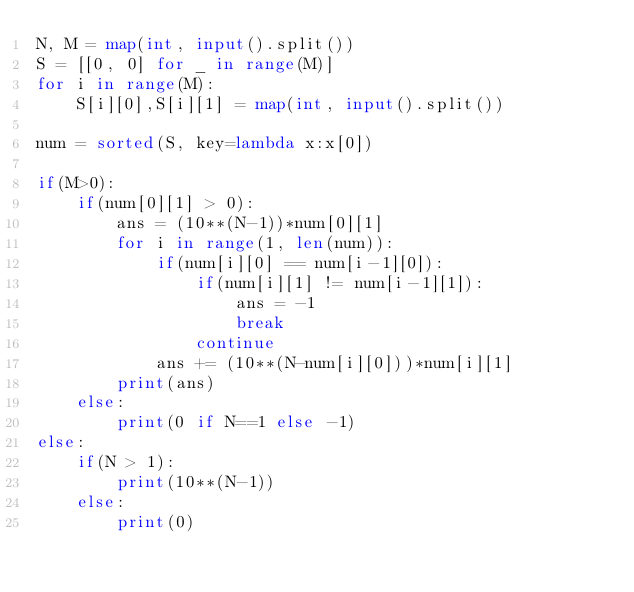Convert code to text. <code><loc_0><loc_0><loc_500><loc_500><_Python_>N, M = map(int, input().split())
S = [[0, 0] for _ in range(M)]
for i in range(M):
    S[i][0],S[i][1] = map(int, input().split())
    
num = sorted(S, key=lambda x:x[0])

if(M>0):
    if(num[0][1] > 0):
        ans = (10**(N-1))*num[0][1]
        for i in range(1, len(num)):
            if(num[i][0] == num[i-1][0]):
                if(num[i][1] != num[i-1][1]):
                    ans = -1
                    break
                continue
            ans += (10**(N-num[i][0]))*num[i][1]
        print(ans)
    else:
        print(0 if N==1 else -1)
else:
    if(N > 1):
        print(10**(N-1))
    else:
        print(0)</code> 